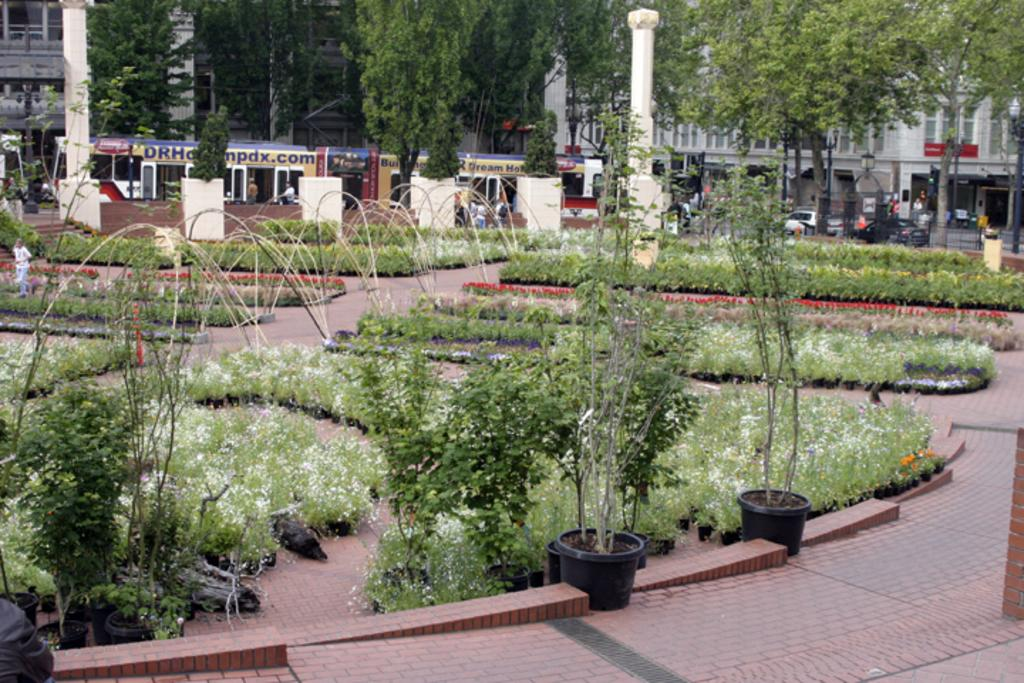What type of living organisms can be seen in the image? Plants can be seen in the image. What are the plants contained in? There are plant pots in the image. What can be seen in the background of the image? Vehicles, buildings, and trees can be seen in the background of the image. What type of fan is visible in the image? There is no fan present in the image. How much was the payment for the plants in the image? There is no information about payment in the image, as it only shows plants and plant pots. 